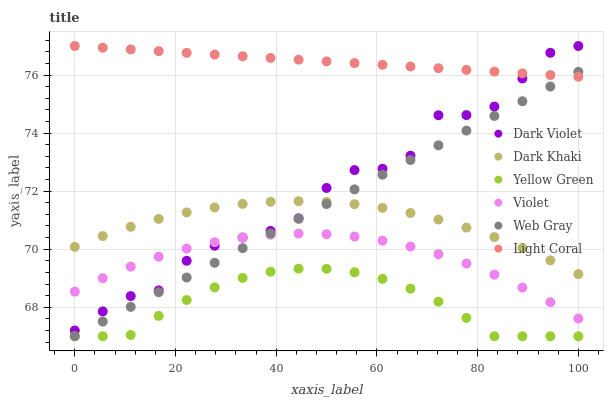Does Yellow Green have the minimum area under the curve?
Answer yes or no. Yes. Does Light Coral have the maximum area under the curve?
Answer yes or no. Yes. Does Web Gray have the minimum area under the curve?
Answer yes or no. No. Does Web Gray have the maximum area under the curve?
Answer yes or no. No. Is Light Coral the smoothest?
Answer yes or no. Yes. Is Dark Violet the roughest?
Answer yes or no. Yes. Is Web Gray the smoothest?
Answer yes or no. No. Is Web Gray the roughest?
Answer yes or no. No. Does Web Gray have the lowest value?
Answer yes or no. Yes. Does Dark Violet have the lowest value?
Answer yes or no. No. Does Dark Violet have the highest value?
Answer yes or no. Yes. Does Web Gray have the highest value?
Answer yes or no. No. Is Yellow Green less than Dark Khaki?
Answer yes or no. Yes. Is Dark Violet greater than Yellow Green?
Answer yes or no. Yes. Does Dark Violet intersect Light Coral?
Answer yes or no. Yes. Is Dark Violet less than Light Coral?
Answer yes or no. No. Is Dark Violet greater than Light Coral?
Answer yes or no. No. Does Yellow Green intersect Dark Khaki?
Answer yes or no. No. 